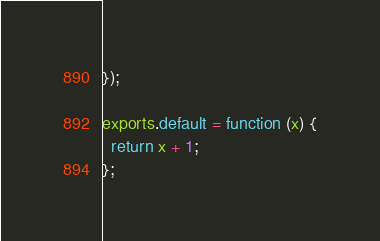Convert code to text. <code><loc_0><loc_0><loc_500><loc_500><_JavaScript_>});

exports.default = function (x) {
  return x + 1;
};</code> 